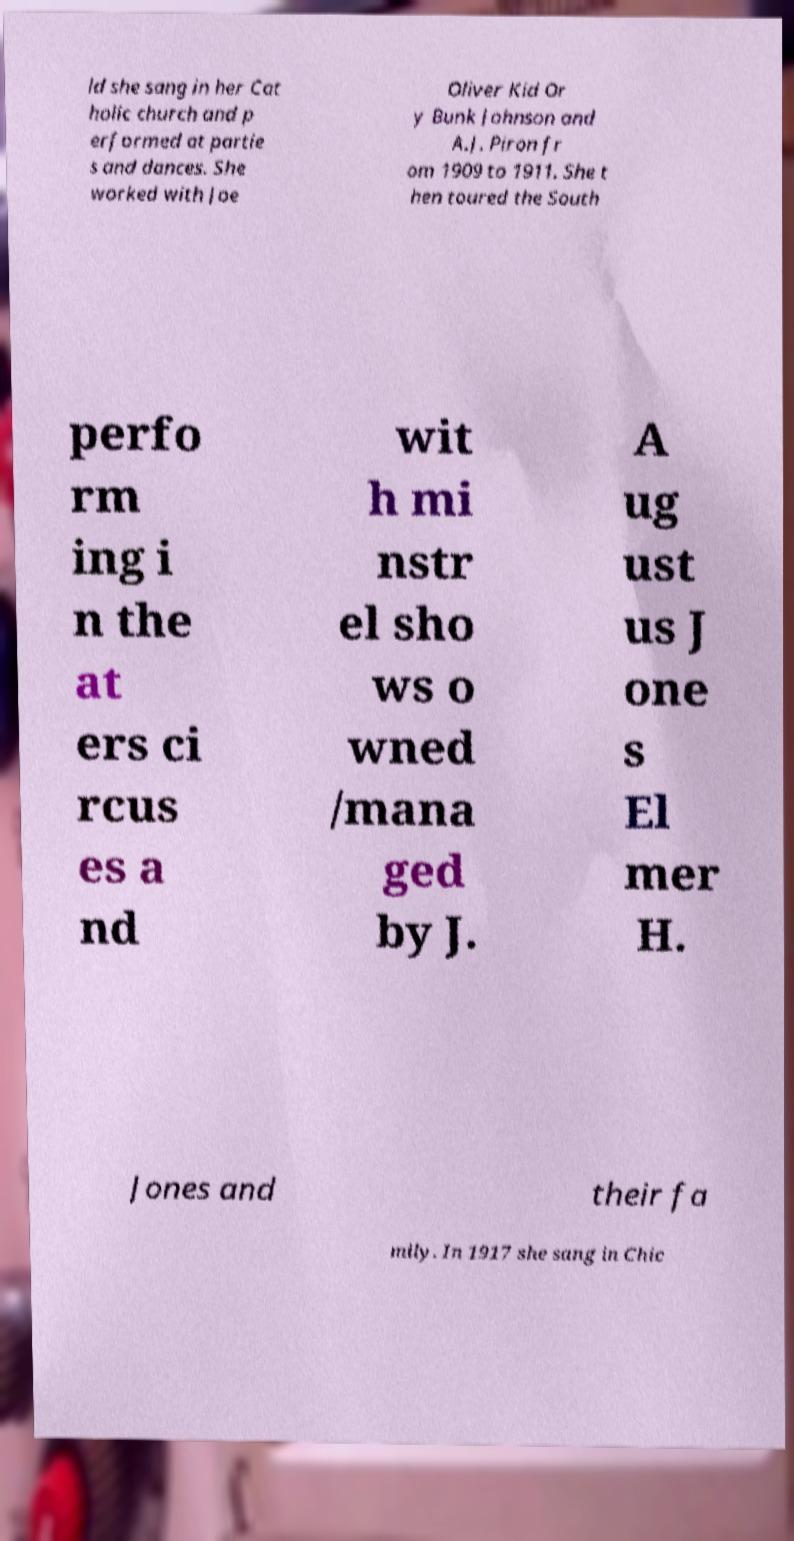Could you assist in decoding the text presented in this image and type it out clearly? ld she sang in her Cat holic church and p erformed at partie s and dances. She worked with Joe Oliver Kid Or y Bunk Johnson and A.J. Piron fr om 1909 to 1911. She t hen toured the South perfo rm ing i n the at ers ci rcus es a nd wit h mi nstr el sho ws o wned /mana ged by J. A ug ust us J one s El mer H. Jones and their fa mily. In 1917 she sang in Chic 